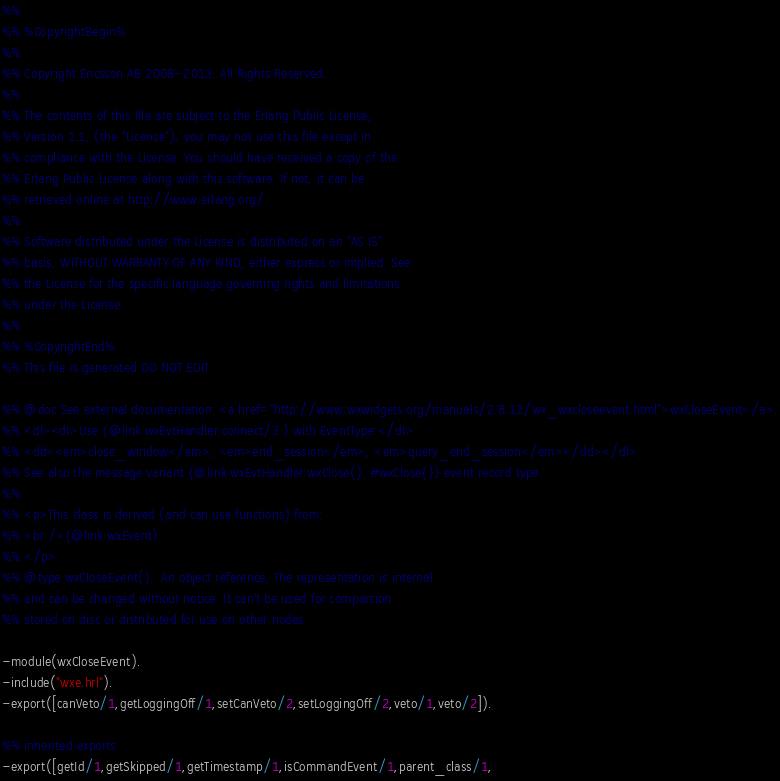<code> <loc_0><loc_0><loc_500><loc_500><_Erlang_>%%
%% %CopyrightBegin%
%%
%% Copyright Ericsson AB 2008-2013. All Rights Reserved.
%%
%% The contents of this file are subject to the Erlang Public License,
%% Version 1.1, (the "License"); you may not use this file except in
%% compliance with the License. You should have received a copy of the
%% Erlang Public License along with this software. If not, it can be
%% retrieved online at http://www.erlang.org/.
%%
%% Software distributed under the License is distributed on an "AS IS"
%% basis, WITHOUT WARRANTY OF ANY KIND, either express or implied. See
%% the License for the specific language governing rights and limitations
%% under the License.
%%
%% %CopyrightEnd%
%% This file is generated DO NOT EDIT

%% @doc See external documentation: <a href="http://www.wxwidgets.org/manuals/2.8.12/wx_wxcloseevent.html">wxCloseEvent</a>.
%% <dl><dt>Use {@link wxEvtHandler:connect/3.} with EventType:</dt>
%% <dd><em>close_window</em>, <em>end_session</em>, <em>query_end_session</em></dd></dl>
%% See also the message variant {@link wxEvtHandler:wxClose(). #wxClose{}} event record type.
%%
%% <p>This class is derived (and can use functions) from:
%% <br />{@link wxEvent}
%% </p>
%% @type wxCloseEvent().  An object reference, The representation is internal
%% and can be changed without notice. It can't be used for comparsion
%% stored on disc or distributed for use on other nodes.

-module(wxCloseEvent).
-include("wxe.hrl").
-export([canVeto/1,getLoggingOff/1,setCanVeto/2,setLoggingOff/2,veto/1,veto/2]).

%% inherited exports
-export([getId/1,getSkipped/1,getTimestamp/1,isCommandEvent/1,parent_class/1,</code> 